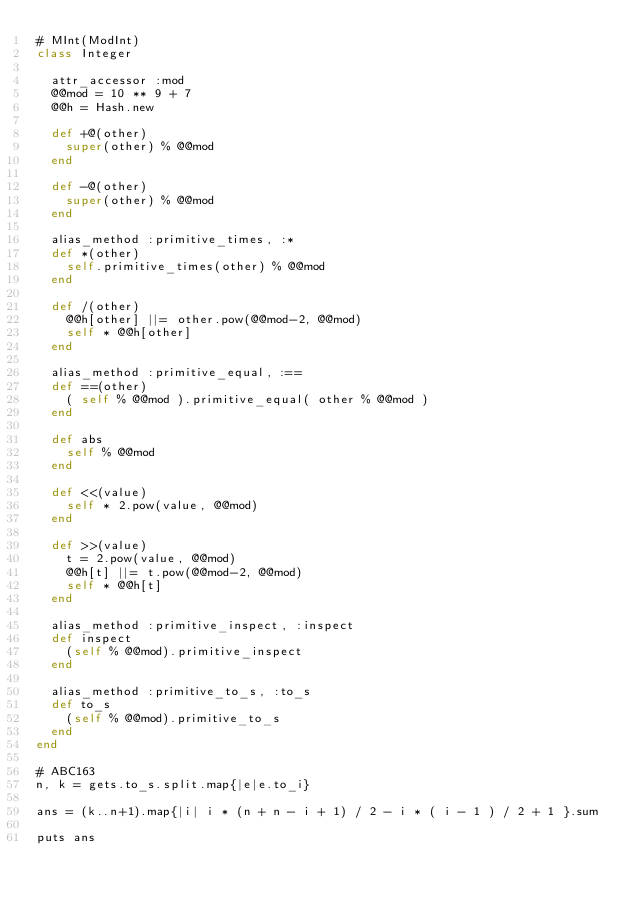Convert code to text. <code><loc_0><loc_0><loc_500><loc_500><_Ruby_># MInt(ModInt)
class Integer

  attr_accessor :mod
  @@mod = 10 ** 9 + 7
  @@h = Hash.new

  def +@(other)
    super(other) % @@mod
  end

  def -@(other)
    super(other) % @@mod
  end

  alias_method :primitive_times, :*
  def *(other)
    self.primitive_times(other) % @@mod
  end

  def /(other)
    @@h[other] ||= other.pow(@@mod-2, @@mod)
    self * @@h[other]
  end
  
  alias_method :primitive_equal, :==
  def ==(other)
    ( self % @@mod ).primitive_equal( other % @@mod )
  end
  
  def abs
    self % @@mod
  end
  
  def <<(value)
    self * 2.pow(value, @@mod)
  end
  
  def >>(value)
    t = 2.pow(value, @@mod)
    @@h[t] ||= t.pow(@@mod-2, @@mod)
    self * @@h[t]
  end
  
  alias_method :primitive_inspect, :inspect
  def inspect
    (self % @@mod).primitive_inspect
  end

  alias_method :primitive_to_s, :to_s
  def to_s
    (self % @@mod).primitive_to_s
  end
end

# ABC163
n, k = gets.to_s.split.map{|e|e.to_i}

ans = (k..n+1).map{|i| i * (n + n - i + 1) / 2 - i * ( i - 1 ) / 2 + 1 }.sum

puts ans</code> 